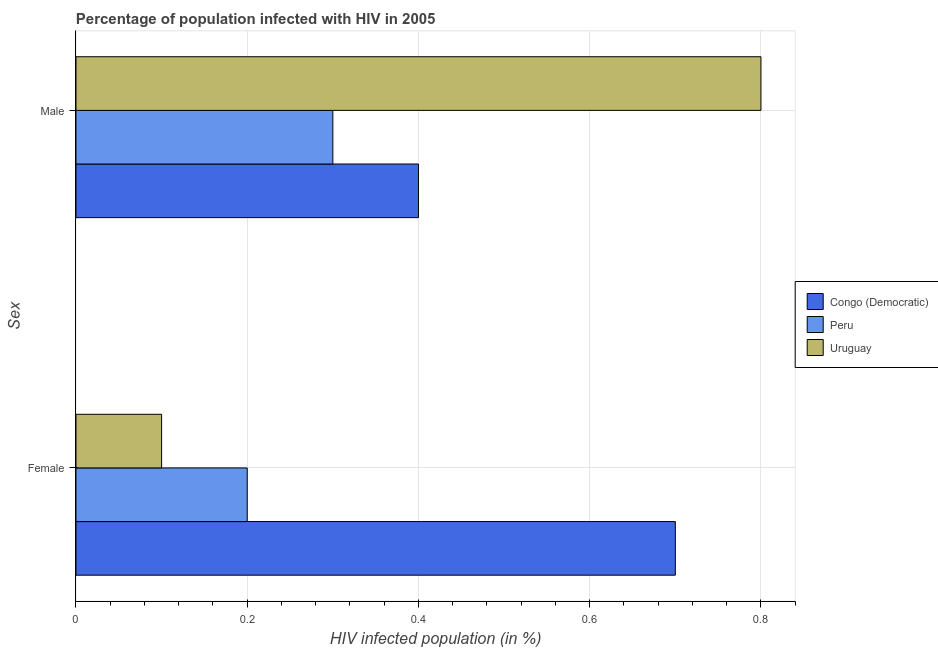How many groups of bars are there?
Provide a short and direct response. 2. Are the number of bars per tick equal to the number of legend labels?
Your response must be concise. Yes. In which country was the percentage of females who are infected with hiv maximum?
Your answer should be very brief. Congo (Democratic). In which country was the percentage of females who are infected with hiv minimum?
Keep it short and to the point. Uruguay. What is the difference between the percentage of males who are infected with hiv in Uruguay and that in Congo (Democratic)?
Provide a succinct answer. 0.4. What is the difference between the percentage of males who are infected with hiv in Peru and the percentage of females who are infected with hiv in Congo (Democratic)?
Provide a short and direct response. -0.4. What is the average percentage of males who are infected with hiv per country?
Provide a short and direct response. 0.5. What is the difference between the percentage of females who are infected with hiv and percentage of males who are infected with hiv in Congo (Democratic)?
Offer a terse response. 0.3. In how many countries, is the percentage of males who are infected with hiv greater than the average percentage of males who are infected with hiv taken over all countries?
Make the answer very short. 1. What does the 1st bar from the top in Female represents?
Your answer should be compact. Uruguay. What does the 1st bar from the bottom in Male represents?
Your response must be concise. Congo (Democratic). How many bars are there?
Your response must be concise. 6. How many countries are there in the graph?
Keep it short and to the point. 3. What is the difference between two consecutive major ticks on the X-axis?
Ensure brevity in your answer.  0.2. Are the values on the major ticks of X-axis written in scientific E-notation?
Your answer should be compact. No. Does the graph contain grids?
Provide a succinct answer. Yes. How are the legend labels stacked?
Provide a short and direct response. Vertical. What is the title of the graph?
Your answer should be very brief. Percentage of population infected with HIV in 2005. What is the label or title of the X-axis?
Make the answer very short. HIV infected population (in %). What is the label or title of the Y-axis?
Provide a succinct answer. Sex. What is the HIV infected population (in %) in Congo (Democratic) in Female?
Your response must be concise. 0.7. What is the HIV infected population (in %) in Peru in Female?
Provide a succinct answer. 0.2. What is the HIV infected population (in %) in Congo (Democratic) in Male?
Keep it short and to the point. 0.4. What is the HIV infected population (in %) in Peru in Male?
Keep it short and to the point. 0.3. Across all Sex, what is the maximum HIV infected population (in %) of Congo (Democratic)?
Make the answer very short. 0.7. Across all Sex, what is the maximum HIV infected population (in %) of Uruguay?
Provide a succinct answer. 0.8. Across all Sex, what is the minimum HIV infected population (in %) of Congo (Democratic)?
Ensure brevity in your answer.  0.4. What is the total HIV infected population (in %) in Congo (Democratic) in the graph?
Provide a succinct answer. 1.1. What is the difference between the HIV infected population (in %) in Peru in Female and that in Male?
Your answer should be very brief. -0.1. What is the difference between the HIV infected population (in %) in Peru in Female and the HIV infected population (in %) in Uruguay in Male?
Provide a succinct answer. -0.6. What is the average HIV infected population (in %) in Congo (Democratic) per Sex?
Offer a very short reply. 0.55. What is the average HIV infected population (in %) in Peru per Sex?
Offer a very short reply. 0.25. What is the average HIV infected population (in %) of Uruguay per Sex?
Your answer should be compact. 0.45. What is the difference between the HIV infected population (in %) in Congo (Democratic) and HIV infected population (in %) in Peru in Female?
Your response must be concise. 0.5. What is the difference between the HIV infected population (in %) of Congo (Democratic) and HIV infected population (in %) of Uruguay in Female?
Give a very brief answer. 0.6. What is the difference between the HIV infected population (in %) of Peru and HIV infected population (in %) of Uruguay in Female?
Provide a succinct answer. 0.1. What is the ratio of the HIV infected population (in %) in Congo (Democratic) in Female to that in Male?
Offer a terse response. 1.75. What is the difference between the highest and the second highest HIV infected population (in %) of Congo (Democratic)?
Offer a terse response. 0.3. What is the difference between the highest and the lowest HIV infected population (in %) in Uruguay?
Give a very brief answer. 0.7. 